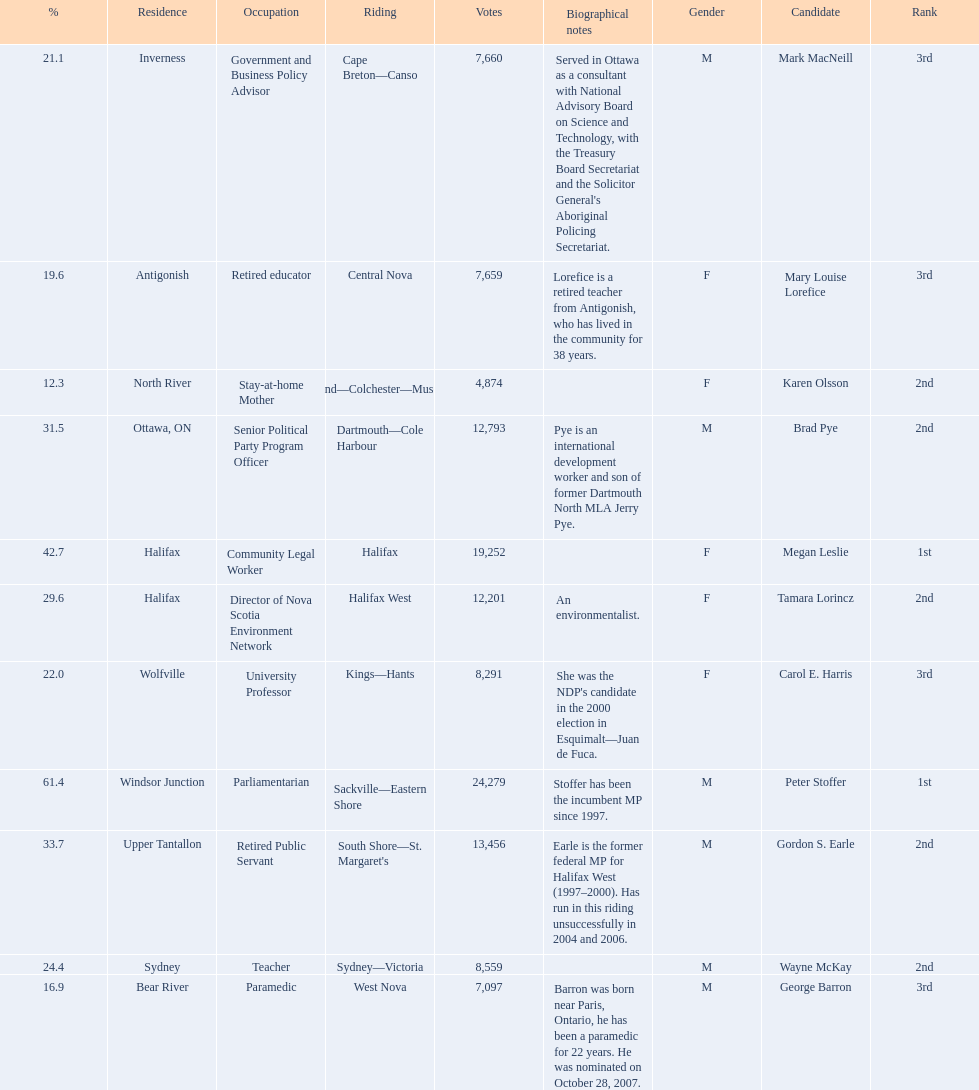Who were all of the new democratic party candidates during the 2008 canadian federal election? Mark MacNeill, Mary Louise Lorefice, Karen Olsson, Brad Pye, Megan Leslie, Tamara Lorincz, Carol E. Harris, Peter Stoffer, Gordon S. Earle, Wayne McKay, George Barron. And between mark macneill and karen olsson, which candidate received more votes? Mark MacNeill. 